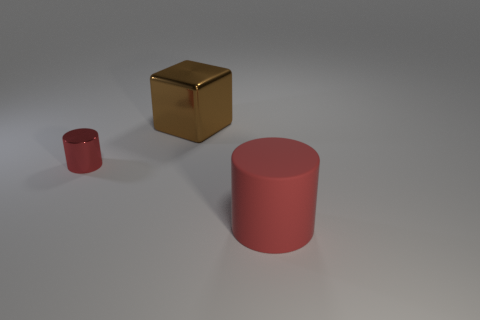Subtract all gray cylinders. Subtract all yellow spheres. How many cylinders are left? 2 Add 2 brown rubber things. How many objects exist? 5 Subtract all cylinders. How many objects are left? 1 Add 3 tiny shiny things. How many tiny shiny things are left? 4 Add 2 blue rubber things. How many blue rubber things exist? 2 Subtract 0 purple cylinders. How many objects are left? 3 Subtract all small gray metal cylinders. Subtract all big things. How many objects are left? 1 